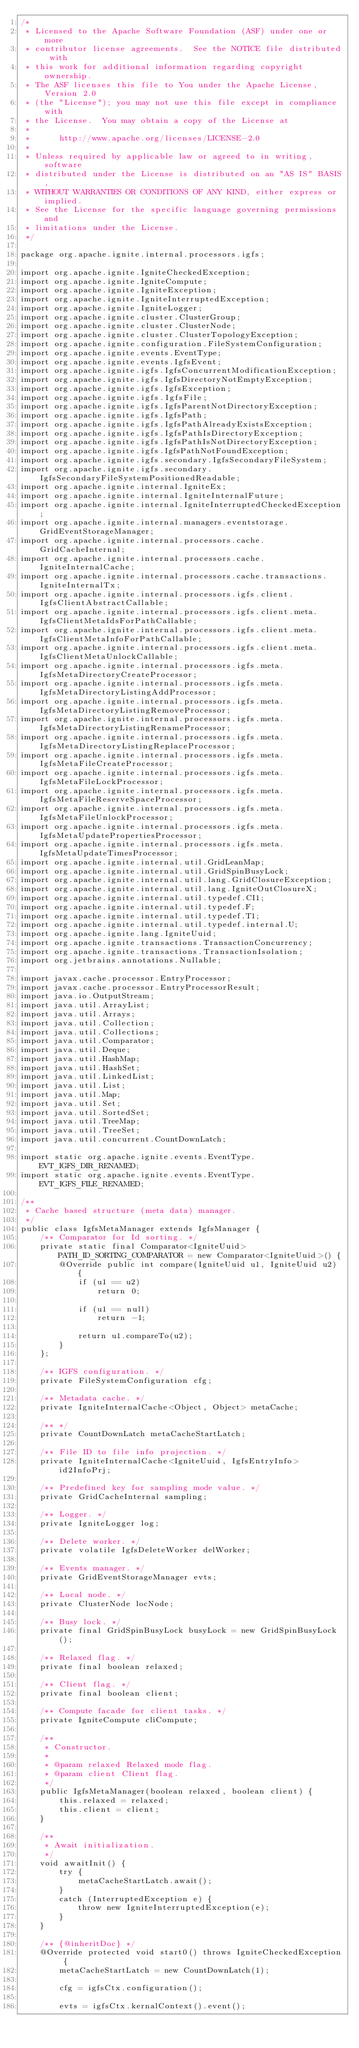<code> <loc_0><loc_0><loc_500><loc_500><_Java_>/*
 * Licensed to the Apache Software Foundation (ASF) under one or more
 * contributor license agreements.  See the NOTICE file distributed with
 * this work for additional information regarding copyright ownership.
 * The ASF licenses this file to You under the Apache License, Version 2.0
 * (the "License"); you may not use this file except in compliance with
 * the License.  You may obtain a copy of the License at
 *
 *      http://www.apache.org/licenses/LICENSE-2.0
 *
 * Unless required by applicable law or agreed to in writing, software
 * distributed under the License is distributed on an "AS IS" BASIS,
 * WITHOUT WARRANTIES OR CONDITIONS OF ANY KIND, either express or implied.
 * See the License for the specific language governing permissions and
 * limitations under the License.
 */

package org.apache.ignite.internal.processors.igfs;

import org.apache.ignite.IgniteCheckedException;
import org.apache.ignite.IgniteCompute;
import org.apache.ignite.IgniteException;
import org.apache.ignite.IgniteInterruptedException;
import org.apache.ignite.IgniteLogger;
import org.apache.ignite.cluster.ClusterGroup;
import org.apache.ignite.cluster.ClusterNode;
import org.apache.ignite.cluster.ClusterTopologyException;
import org.apache.ignite.configuration.FileSystemConfiguration;
import org.apache.ignite.events.EventType;
import org.apache.ignite.events.IgfsEvent;
import org.apache.ignite.igfs.IgfsConcurrentModificationException;
import org.apache.ignite.igfs.IgfsDirectoryNotEmptyException;
import org.apache.ignite.igfs.IgfsException;
import org.apache.ignite.igfs.IgfsFile;
import org.apache.ignite.igfs.IgfsParentNotDirectoryException;
import org.apache.ignite.igfs.IgfsPath;
import org.apache.ignite.igfs.IgfsPathAlreadyExistsException;
import org.apache.ignite.igfs.IgfsPathIsDirectoryException;
import org.apache.ignite.igfs.IgfsPathIsNotDirectoryException;
import org.apache.ignite.igfs.IgfsPathNotFoundException;
import org.apache.ignite.igfs.secondary.IgfsSecondaryFileSystem;
import org.apache.ignite.igfs.secondary.IgfsSecondaryFileSystemPositionedReadable;
import org.apache.ignite.internal.IgniteEx;
import org.apache.ignite.internal.IgniteInternalFuture;
import org.apache.ignite.internal.IgniteInterruptedCheckedException;
import org.apache.ignite.internal.managers.eventstorage.GridEventStorageManager;
import org.apache.ignite.internal.processors.cache.GridCacheInternal;
import org.apache.ignite.internal.processors.cache.IgniteInternalCache;
import org.apache.ignite.internal.processors.cache.transactions.IgniteInternalTx;
import org.apache.ignite.internal.processors.igfs.client.IgfsClientAbstractCallable;
import org.apache.ignite.internal.processors.igfs.client.meta.IgfsClientMetaIdsForPathCallable;
import org.apache.ignite.internal.processors.igfs.client.meta.IgfsClientMetaInfoForPathCallable;
import org.apache.ignite.internal.processors.igfs.client.meta.IgfsClientMetaUnlockCallable;
import org.apache.ignite.internal.processors.igfs.meta.IgfsMetaDirectoryCreateProcessor;
import org.apache.ignite.internal.processors.igfs.meta.IgfsMetaDirectoryListingAddProcessor;
import org.apache.ignite.internal.processors.igfs.meta.IgfsMetaDirectoryListingRemoveProcessor;
import org.apache.ignite.internal.processors.igfs.meta.IgfsMetaDirectoryListingRenameProcessor;
import org.apache.ignite.internal.processors.igfs.meta.IgfsMetaDirectoryListingReplaceProcessor;
import org.apache.ignite.internal.processors.igfs.meta.IgfsMetaFileCreateProcessor;
import org.apache.ignite.internal.processors.igfs.meta.IgfsMetaFileLockProcessor;
import org.apache.ignite.internal.processors.igfs.meta.IgfsMetaFileReserveSpaceProcessor;
import org.apache.ignite.internal.processors.igfs.meta.IgfsMetaFileUnlockProcessor;
import org.apache.ignite.internal.processors.igfs.meta.IgfsMetaUpdatePropertiesProcessor;
import org.apache.ignite.internal.processors.igfs.meta.IgfsMetaUpdateTimesProcessor;
import org.apache.ignite.internal.util.GridLeanMap;
import org.apache.ignite.internal.util.GridSpinBusyLock;
import org.apache.ignite.internal.util.lang.GridClosureException;
import org.apache.ignite.internal.util.lang.IgniteOutClosureX;
import org.apache.ignite.internal.util.typedef.CI1;
import org.apache.ignite.internal.util.typedef.F;
import org.apache.ignite.internal.util.typedef.T1;
import org.apache.ignite.internal.util.typedef.internal.U;
import org.apache.ignite.lang.IgniteUuid;
import org.apache.ignite.transactions.TransactionConcurrency;
import org.apache.ignite.transactions.TransactionIsolation;
import org.jetbrains.annotations.Nullable;

import javax.cache.processor.EntryProcessor;
import javax.cache.processor.EntryProcessorResult;
import java.io.OutputStream;
import java.util.ArrayList;
import java.util.Arrays;
import java.util.Collection;
import java.util.Collections;
import java.util.Comparator;
import java.util.Deque;
import java.util.HashMap;
import java.util.HashSet;
import java.util.LinkedList;
import java.util.List;
import java.util.Map;
import java.util.Set;
import java.util.SortedSet;
import java.util.TreeMap;
import java.util.TreeSet;
import java.util.concurrent.CountDownLatch;

import static org.apache.ignite.events.EventType.EVT_IGFS_DIR_RENAMED;
import static org.apache.ignite.events.EventType.EVT_IGFS_FILE_RENAMED;

/**
 * Cache based structure (meta data) manager.
 */
public class IgfsMetaManager extends IgfsManager {
    /** Comparator for Id sorting. */
    private static final Comparator<IgniteUuid> PATH_ID_SORTING_COMPARATOR = new Comparator<IgniteUuid>() {
        @Override public int compare(IgniteUuid u1, IgniteUuid u2) {
            if (u1 == u2)
                return 0;

            if (u1 == null)
                return -1;

            return u1.compareTo(u2);
        }
    };

    /** IGFS configuration. */
    private FileSystemConfiguration cfg;

    /** Metadata cache. */
    private IgniteInternalCache<Object, Object> metaCache;

    /** */
    private CountDownLatch metaCacheStartLatch;

    /** File ID to file info projection. */
    private IgniteInternalCache<IgniteUuid, IgfsEntryInfo> id2InfoPrj;

    /** Predefined key for sampling mode value. */
    private GridCacheInternal sampling;

    /** Logger. */
    private IgniteLogger log;

    /** Delete worker. */
    private volatile IgfsDeleteWorker delWorker;

    /** Events manager. */
    private GridEventStorageManager evts;

    /** Local node. */
    private ClusterNode locNode;

    /** Busy lock. */
    private final GridSpinBusyLock busyLock = new GridSpinBusyLock();

    /** Relaxed flag. */
    private final boolean relaxed;

    /** Client flag. */
    private final boolean client;

    /** Compute facade for client tasks. */
    private IgniteCompute cliCompute;

    /**
     * Constructor.
     *
     * @param relaxed Relaxed mode flag.
     * @param client Client flag.
     */
    public IgfsMetaManager(boolean relaxed, boolean client) {
        this.relaxed = relaxed;
        this.client = client;
    }

    /**
     * Await initialization.
     */
    void awaitInit() {
        try {
            metaCacheStartLatch.await();
        }
        catch (InterruptedException e) {
            throw new IgniteInterruptedException(e);
        }
    }

    /** {@inheritDoc} */
    @Override protected void start0() throws IgniteCheckedException {
        metaCacheStartLatch = new CountDownLatch(1);

        cfg = igfsCtx.configuration();

        evts = igfsCtx.kernalContext().event();
</code> 